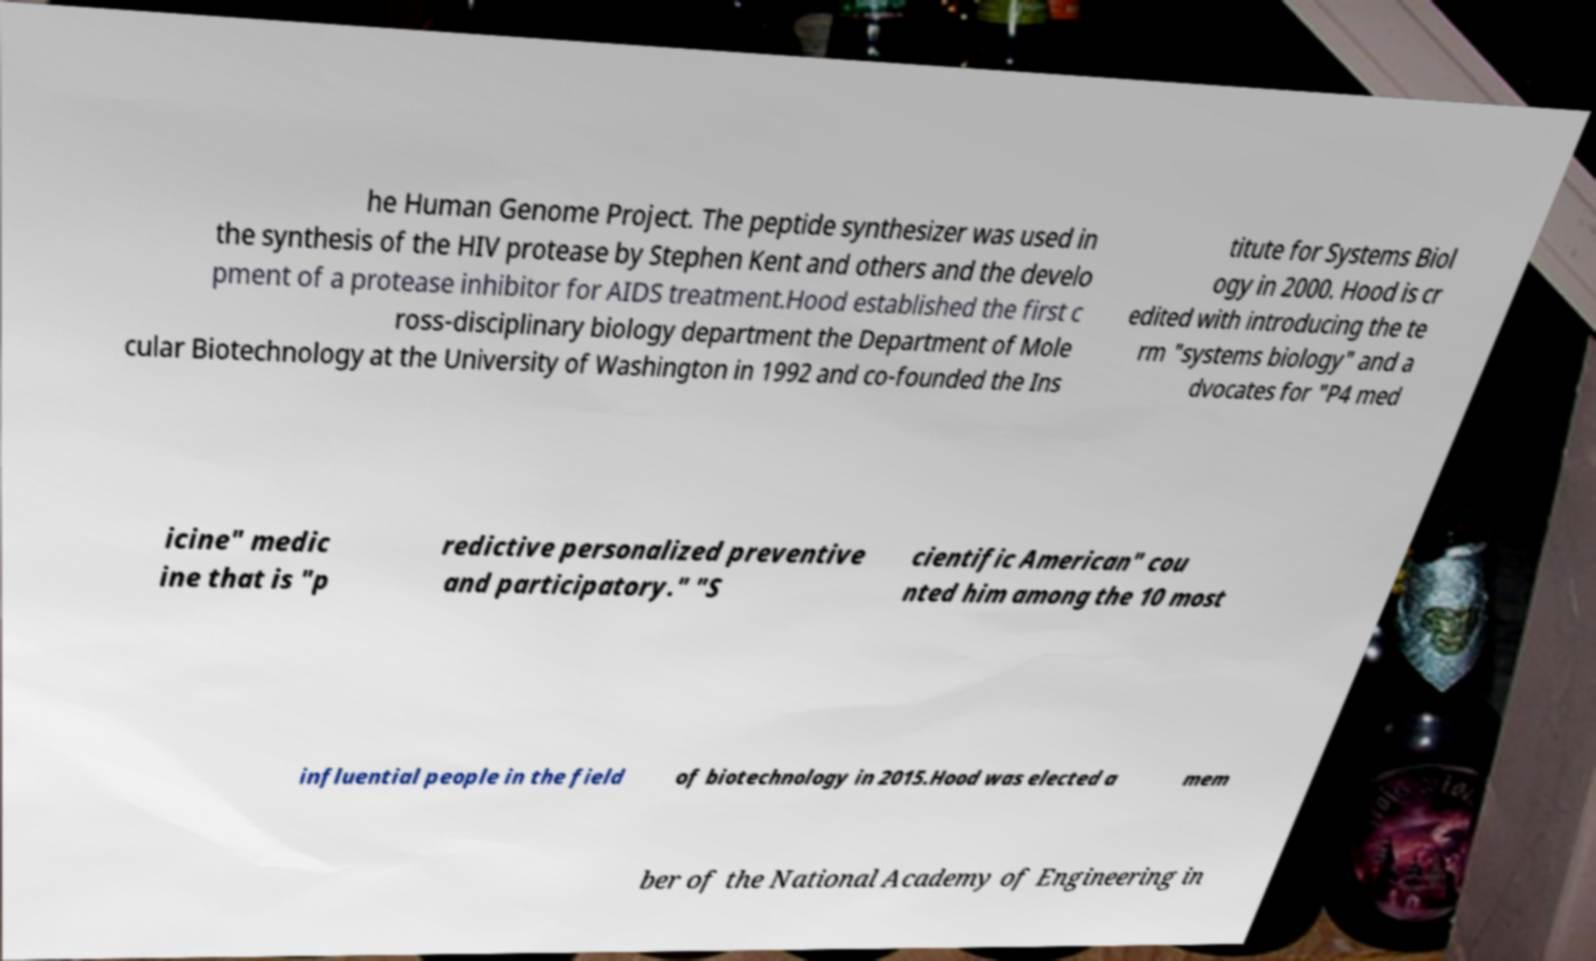Please identify and transcribe the text found in this image. he Human Genome Project. The peptide synthesizer was used in the synthesis of the HIV protease by Stephen Kent and others and the develo pment of a protease inhibitor for AIDS treatment.Hood established the first c ross-disciplinary biology department the Department of Mole cular Biotechnology at the University of Washington in 1992 and co-founded the Ins titute for Systems Biol ogy in 2000. Hood is cr edited with introducing the te rm "systems biology" and a dvocates for "P4 med icine" medic ine that is "p redictive personalized preventive and participatory." "S cientific American" cou nted him among the 10 most influential people in the field of biotechnology in 2015.Hood was elected a mem ber of the National Academy of Engineering in 